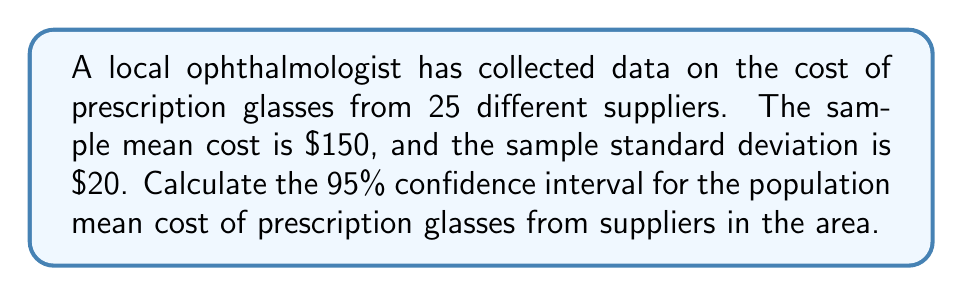Solve this math problem. To calculate the confidence interval, we'll follow these steps:

1) The formula for the confidence interval is:

   $$\bar{x} \pm t_{\alpha/2} \cdot \frac{s}{\sqrt{n}}$$

   where $\bar{x}$ is the sample mean, $s$ is the sample standard deviation, $n$ is the sample size, and $t_{\alpha/2}$ is the t-value for the desired confidence level.

2) We have:
   $\bar{x} = 150$
   $s = 20$
   $n = 25$
   Confidence level = 95%, so $\alpha = 0.05$

3) For a 95% confidence interval with 24 degrees of freedom (n-1), the t-value is approximately 2.064. We can find this using a t-table or statistical software.

4) Now, let's calculate the margin of error:

   $$\text{Margin of Error} = t_{\alpha/2} \cdot \frac{s}{\sqrt{n}} = 2.064 \cdot \frac{20}{\sqrt{25}} = 2.064 \cdot 4 = 8.256$$

5) The confidence interval is therefore:

   $$150 \pm 8.256$$

6) This gives us the interval:

   $$[150 - 8.256, 150 + 8.256] = [141.744, 158.256]$$

Therefore, we can be 95% confident that the true population mean cost of prescription glasses from suppliers in the area falls between $141.74 and $158.26.
Answer: [$141.74, $158.26] 